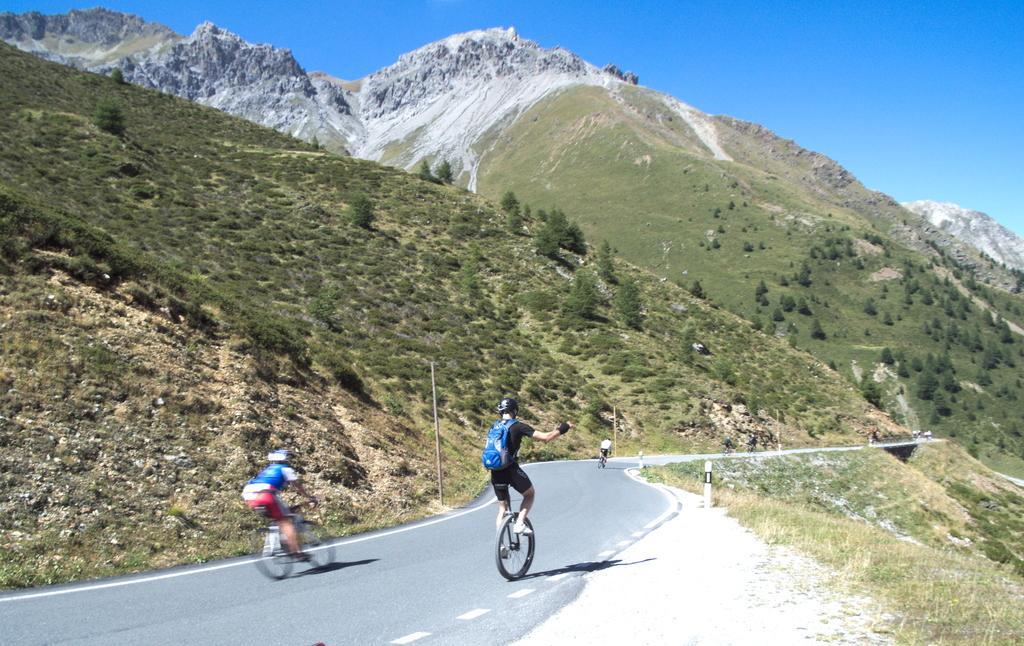Can you describe this image briefly? In the center of the image we can see people riding bicycles on the road. In the background there are hills and sky. On the right there is grass. 